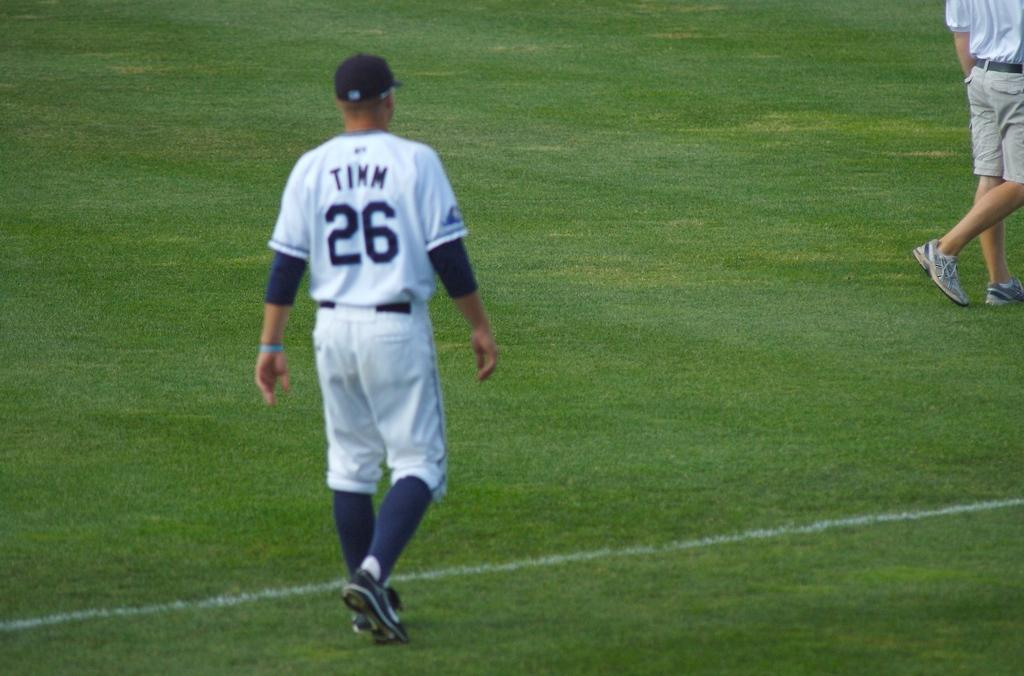<image>
Relay a brief, clear account of the picture shown. Player Timm is walking on the field towards a guy in shorts. 